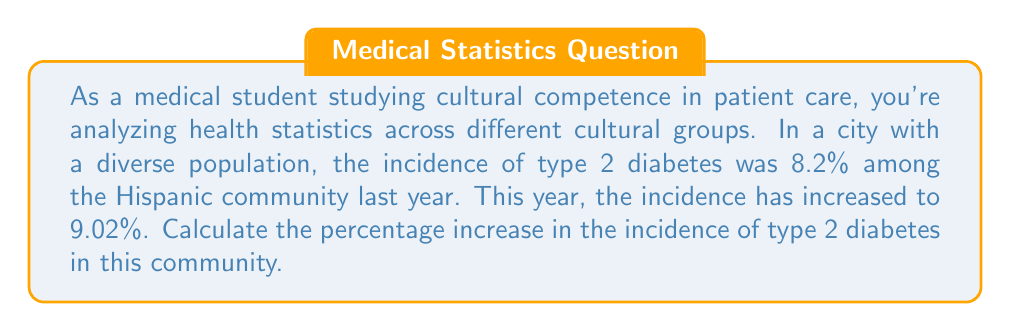Show me your answer to this math problem. To calculate the percentage increase, we need to follow these steps:

1. Calculate the absolute change:
   New value - Original value = $9.02\% - 8.2\% = 0.82\%$

2. Divide the change by the original value:
   $\frac{\text{Change}}{\text{Original value}} = \frac{0.82\%}{8.2\%} = 0.1$

3. Multiply by 100 to get the percentage:
   $0.1 \times 100 = 10\%$

Therefore, the percentage increase in the incidence of type 2 diabetes is 10%.

Alternatively, we can use the percentage change formula:

$$\text{Percentage change} = \frac{\text{New value} - \text{Original value}}{\text{Original value}} \times 100\%$$

$$= \frac{9.02\% - 8.2\%}{8.2\%} \times 100\%$$

$$= \frac{0.82\%}{8.2\%} \times 100\% = 0.1 \times 100\% = 10\%$$

This calculation helps in understanding the relative change in health statistics across different cultural groups, which is crucial for developing culturally competent healthcare strategies.
Answer: 10% 